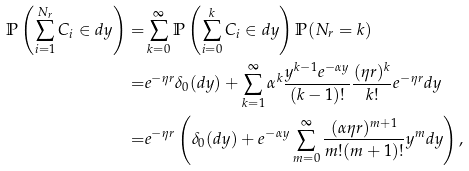<formula> <loc_0><loc_0><loc_500><loc_500>\mathbb { P } \left ( \sum _ { i = 1 } ^ { N _ { r } } C _ { i } \in d y \right ) = & \sum _ { k = 0 } ^ { \infty } \mathbb { P } \left ( \sum _ { i = 0 } ^ { k } C _ { i } \in d y \right ) \mathbb { P } ( N _ { r } = k ) \\ = & e ^ { - \eta r } \delta _ { 0 } ( d y ) + \sum _ { k = 1 } ^ { \infty } \alpha ^ { k } \frac { y ^ { k - 1 } e ^ { - \alpha y } } { ( k - 1 ) ! } \frac { ( \eta r ) ^ { k } } { k ! } e ^ { - \eta r } d y \\ = & e ^ { - \eta r } \left ( \delta _ { 0 } ( d y ) + e ^ { - \alpha y } \sum _ { m = 0 } ^ { \infty } \frac { ( \alpha \eta r ) ^ { m + 1 } } { m ! ( m + 1 ) ! } y ^ { m } d y \right ) ,</formula> 